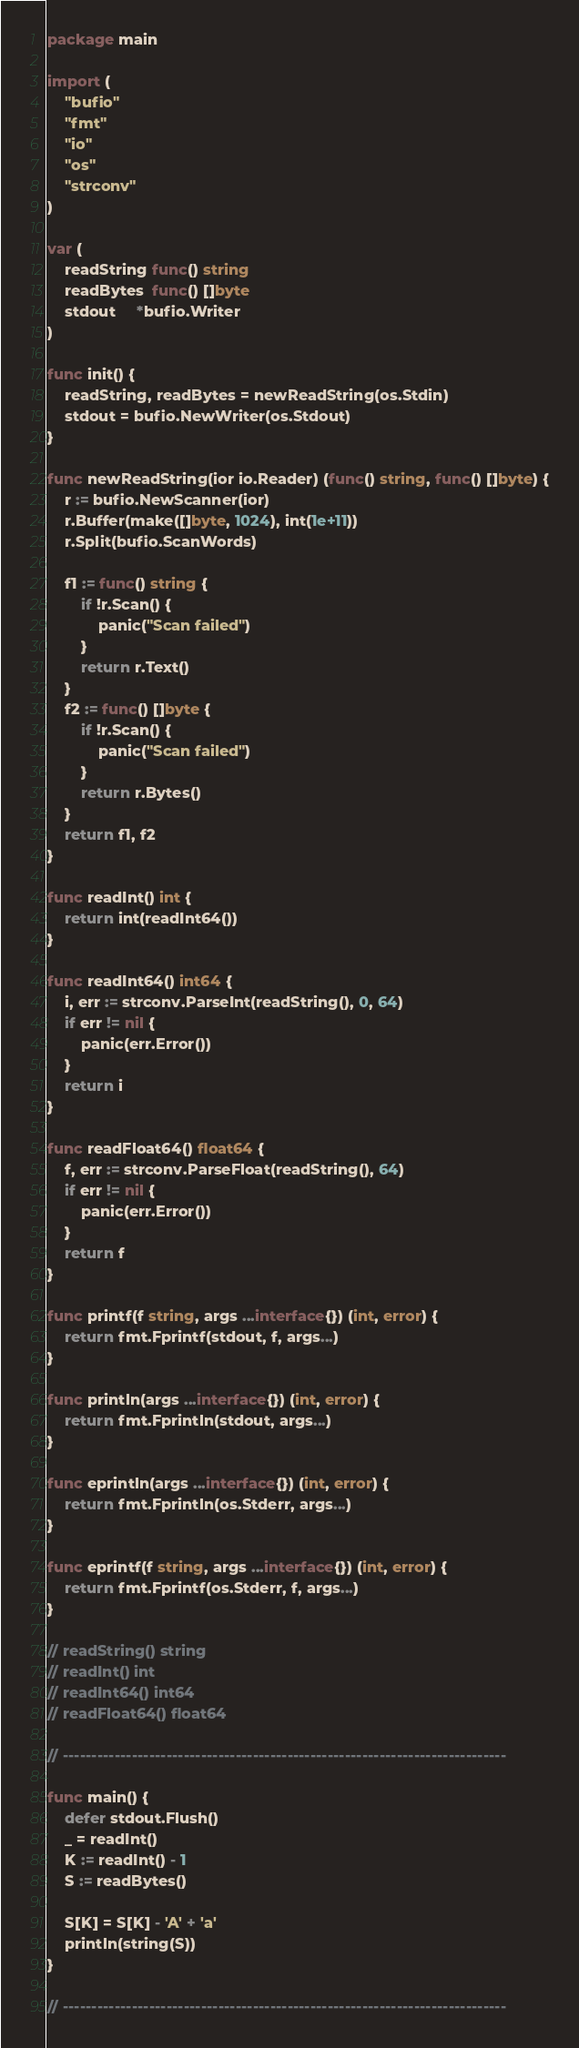<code> <loc_0><loc_0><loc_500><loc_500><_Go_>package main

import (
	"bufio"
	"fmt"
	"io"
	"os"
	"strconv"
)

var (
	readString func() string
	readBytes  func() []byte
	stdout     *bufio.Writer
)

func init() {
	readString, readBytes = newReadString(os.Stdin)
	stdout = bufio.NewWriter(os.Stdout)
}

func newReadString(ior io.Reader) (func() string, func() []byte) {
	r := bufio.NewScanner(ior)
	r.Buffer(make([]byte, 1024), int(1e+11))
	r.Split(bufio.ScanWords)

	f1 := func() string {
		if !r.Scan() {
			panic("Scan failed")
		}
		return r.Text()
	}
	f2 := func() []byte {
		if !r.Scan() {
			panic("Scan failed")
		}
		return r.Bytes()
	}
	return f1, f2
}

func readInt() int {
	return int(readInt64())
}

func readInt64() int64 {
	i, err := strconv.ParseInt(readString(), 0, 64)
	if err != nil {
		panic(err.Error())
	}
	return i
}

func readFloat64() float64 {
	f, err := strconv.ParseFloat(readString(), 64)
	if err != nil {
		panic(err.Error())
	}
	return f
}

func printf(f string, args ...interface{}) (int, error) {
	return fmt.Fprintf(stdout, f, args...)
}

func println(args ...interface{}) (int, error) {
	return fmt.Fprintln(stdout, args...)
}

func eprintln(args ...interface{}) (int, error) {
	return fmt.Fprintln(os.Stderr, args...)
}

func eprintf(f string, args ...interface{}) (int, error) {
	return fmt.Fprintf(os.Stderr, f, args...)
}

// readString() string
// readInt() int
// readInt64() int64
// readFloat64() float64

// -----------------------------------------------------------------------------

func main() {
	defer stdout.Flush()
	_ = readInt()
	K := readInt() - 1
	S := readBytes()

	S[K] = S[K] - 'A' + 'a'
	println(string(S))
}

// -----------------------------------------------------------------------------
</code> 